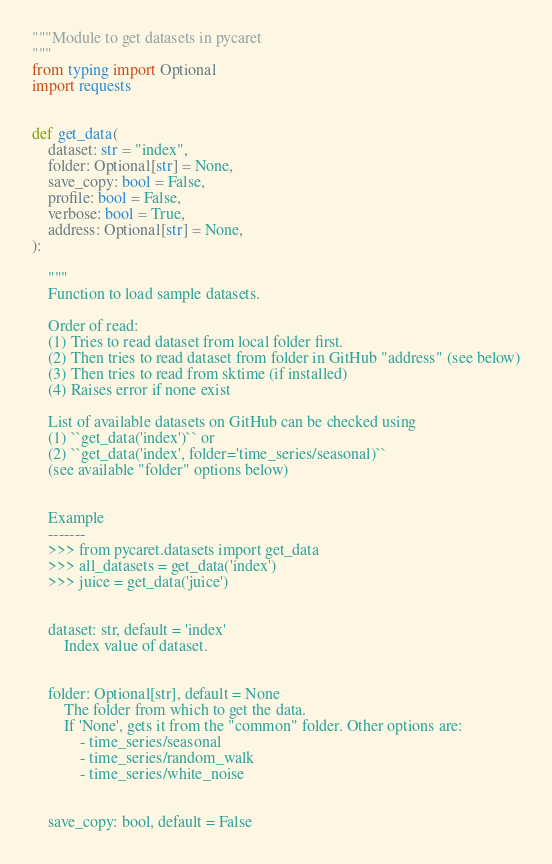<code> <loc_0><loc_0><loc_500><loc_500><_Python_>"""Module to get datasets in pycaret
"""
from typing import Optional
import requests


def get_data(
    dataset: str = "index",
    folder: Optional[str] = None,
    save_copy: bool = False,
    profile: bool = False,
    verbose: bool = True,
    address: Optional[str] = None,
):

    """
    Function to load sample datasets.

    Order of read:
    (1) Tries to read dataset from local folder first.
    (2) Then tries to read dataset from folder in GitHub "address" (see below)
    (3) Then tries to read from sktime (if installed)
    (4) Raises error if none exist

    List of available datasets on GitHub can be checked using
    (1) ``get_data('index')`` or
    (2) ``get_data('index', folder='time_series/seasonal)``
    (see available "folder" options below)


    Example
    -------
    >>> from pycaret.datasets import get_data
    >>> all_datasets = get_data('index')
    >>> juice = get_data('juice')


    dataset: str, default = 'index'
        Index value of dataset.


    folder: Optional[str], default = None
        The folder from which to get the data.
        If 'None', gets it from the "common" folder. Other options are:
            - time_series/seasonal
            - time_series/random_walk
            - time_series/white_noise


    save_copy: bool, default = False</code> 